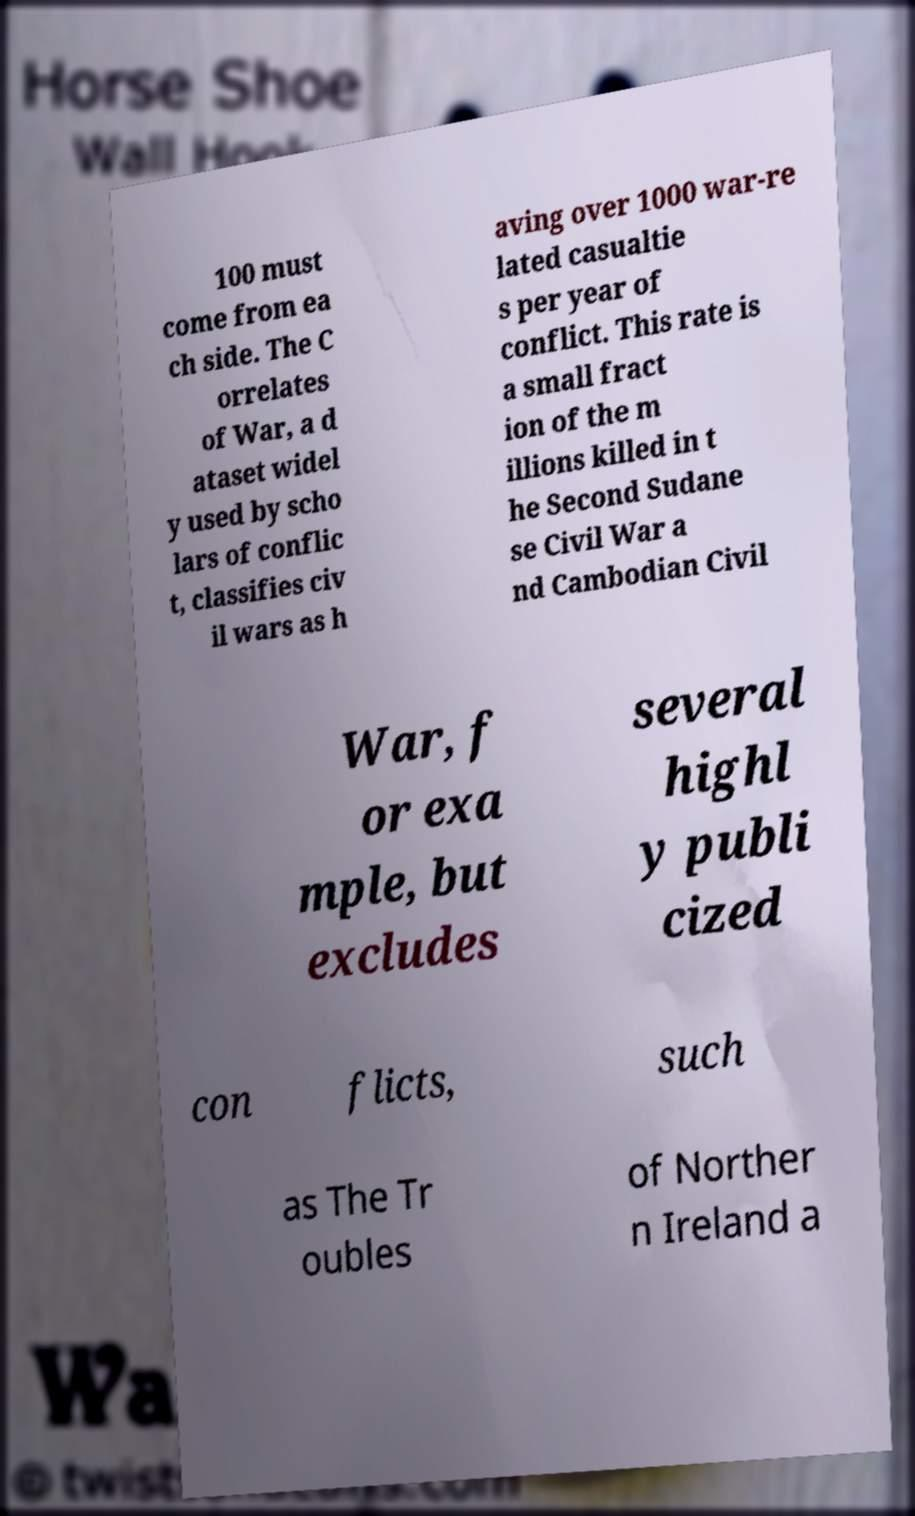What messages or text are displayed in this image? I need them in a readable, typed format. 100 must come from ea ch side. The C orrelates of War, a d ataset widel y used by scho lars of conflic t, classifies civ il wars as h aving over 1000 war-re lated casualtie s per year of conflict. This rate is a small fract ion of the m illions killed in t he Second Sudane se Civil War a nd Cambodian Civil War, f or exa mple, but excludes several highl y publi cized con flicts, such as The Tr oubles of Norther n Ireland a 